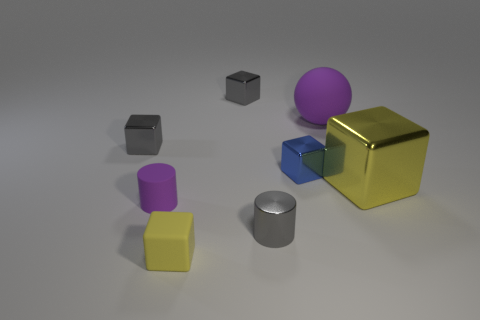Subtract all small gray cubes. How many cubes are left? 3 Add 1 large yellow objects. How many objects exist? 9 Subtract all yellow cubes. How many cubes are left? 3 Subtract all cubes. How many objects are left? 3 Subtract 1 purple spheres. How many objects are left? 7 Subtract 1 spheres. How many spheres are left? 0 Subtract all brown cylinders. Subtract all green spheres. How many cylinders are left? 2 Subtract all blue spheres. How many purple cylinders are left? 1 Subtract all big things. Subtract all tiny blue blocks. How many objects are left? 5 Add 1 tiny blue metal objects. How many tiny blue metal objects are left? 2 